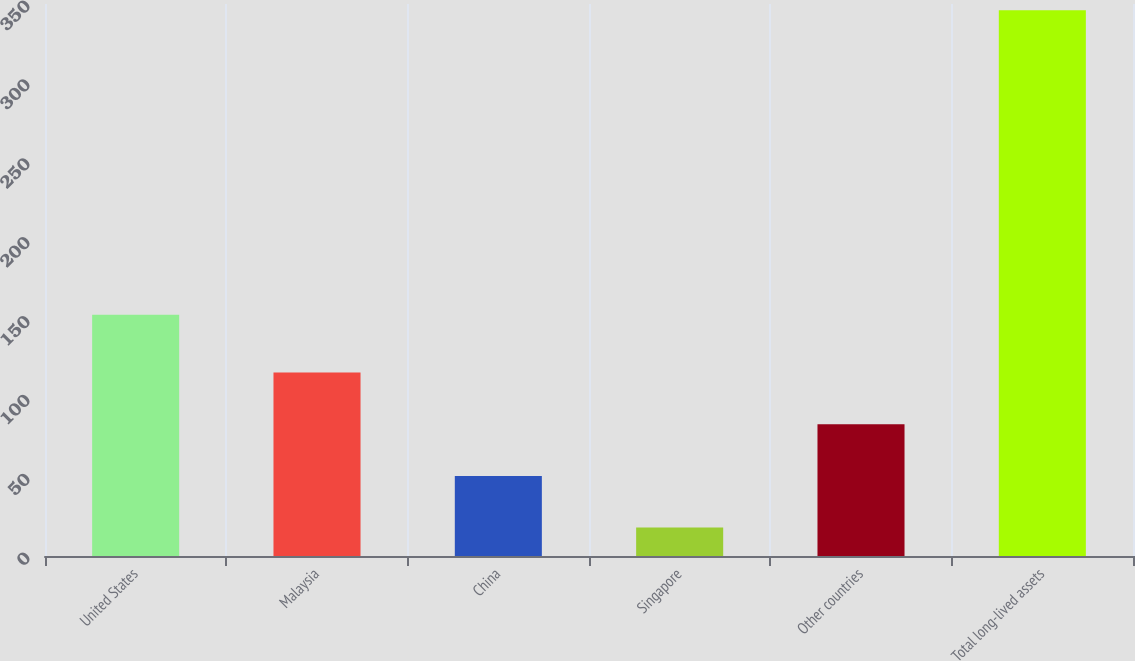<chart> <loc_0><loc_0><loc_500><loc_500><bar_chart><fcel>United States<fcel>Malaysia<fcel>China<fcel>Singapore<fcel>Other countries<fcel>Total long-lived assets<nl><fcel>153<fcel>116.4<fcel>50.8<fcel>18<fcel>83.6<fcel>346<nl></chart> 